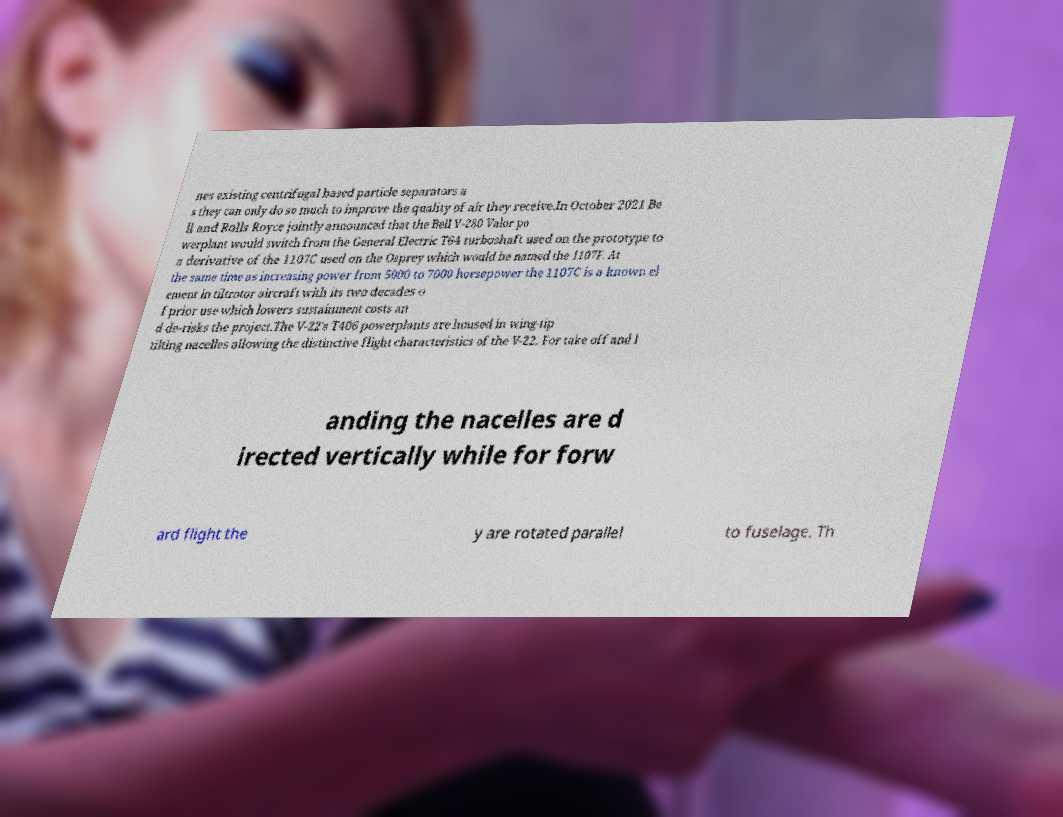Could you extract and type out the text from this image? nes existing centrifugal based particle separators a s they can only do so much to improve the quality of air they receive.In October 2021 Be ll and Rolls Royce jointly announced that the Bell V-280 Valor po werplant would switch from the General Electric T64 turboshaft used on the prototype to a derivative of the 1107C used on the Osprey which would be named the 1107F. At the same time as increasing power from 5000 to 7000 horsepower the 1107C is a known el ement in tiltrotor aircraft with its two decades o f prior use which lowers sustainment costs an d de-risks the project.The V-22's T406 powerplants are housed in wing-tip tilting nacelles allowing the distinctive flight characteristics of the V-22. For take off and l anding the nacelles are d irected vertically while for forw ard flight the y are rotated parallel to fuselage. Th 